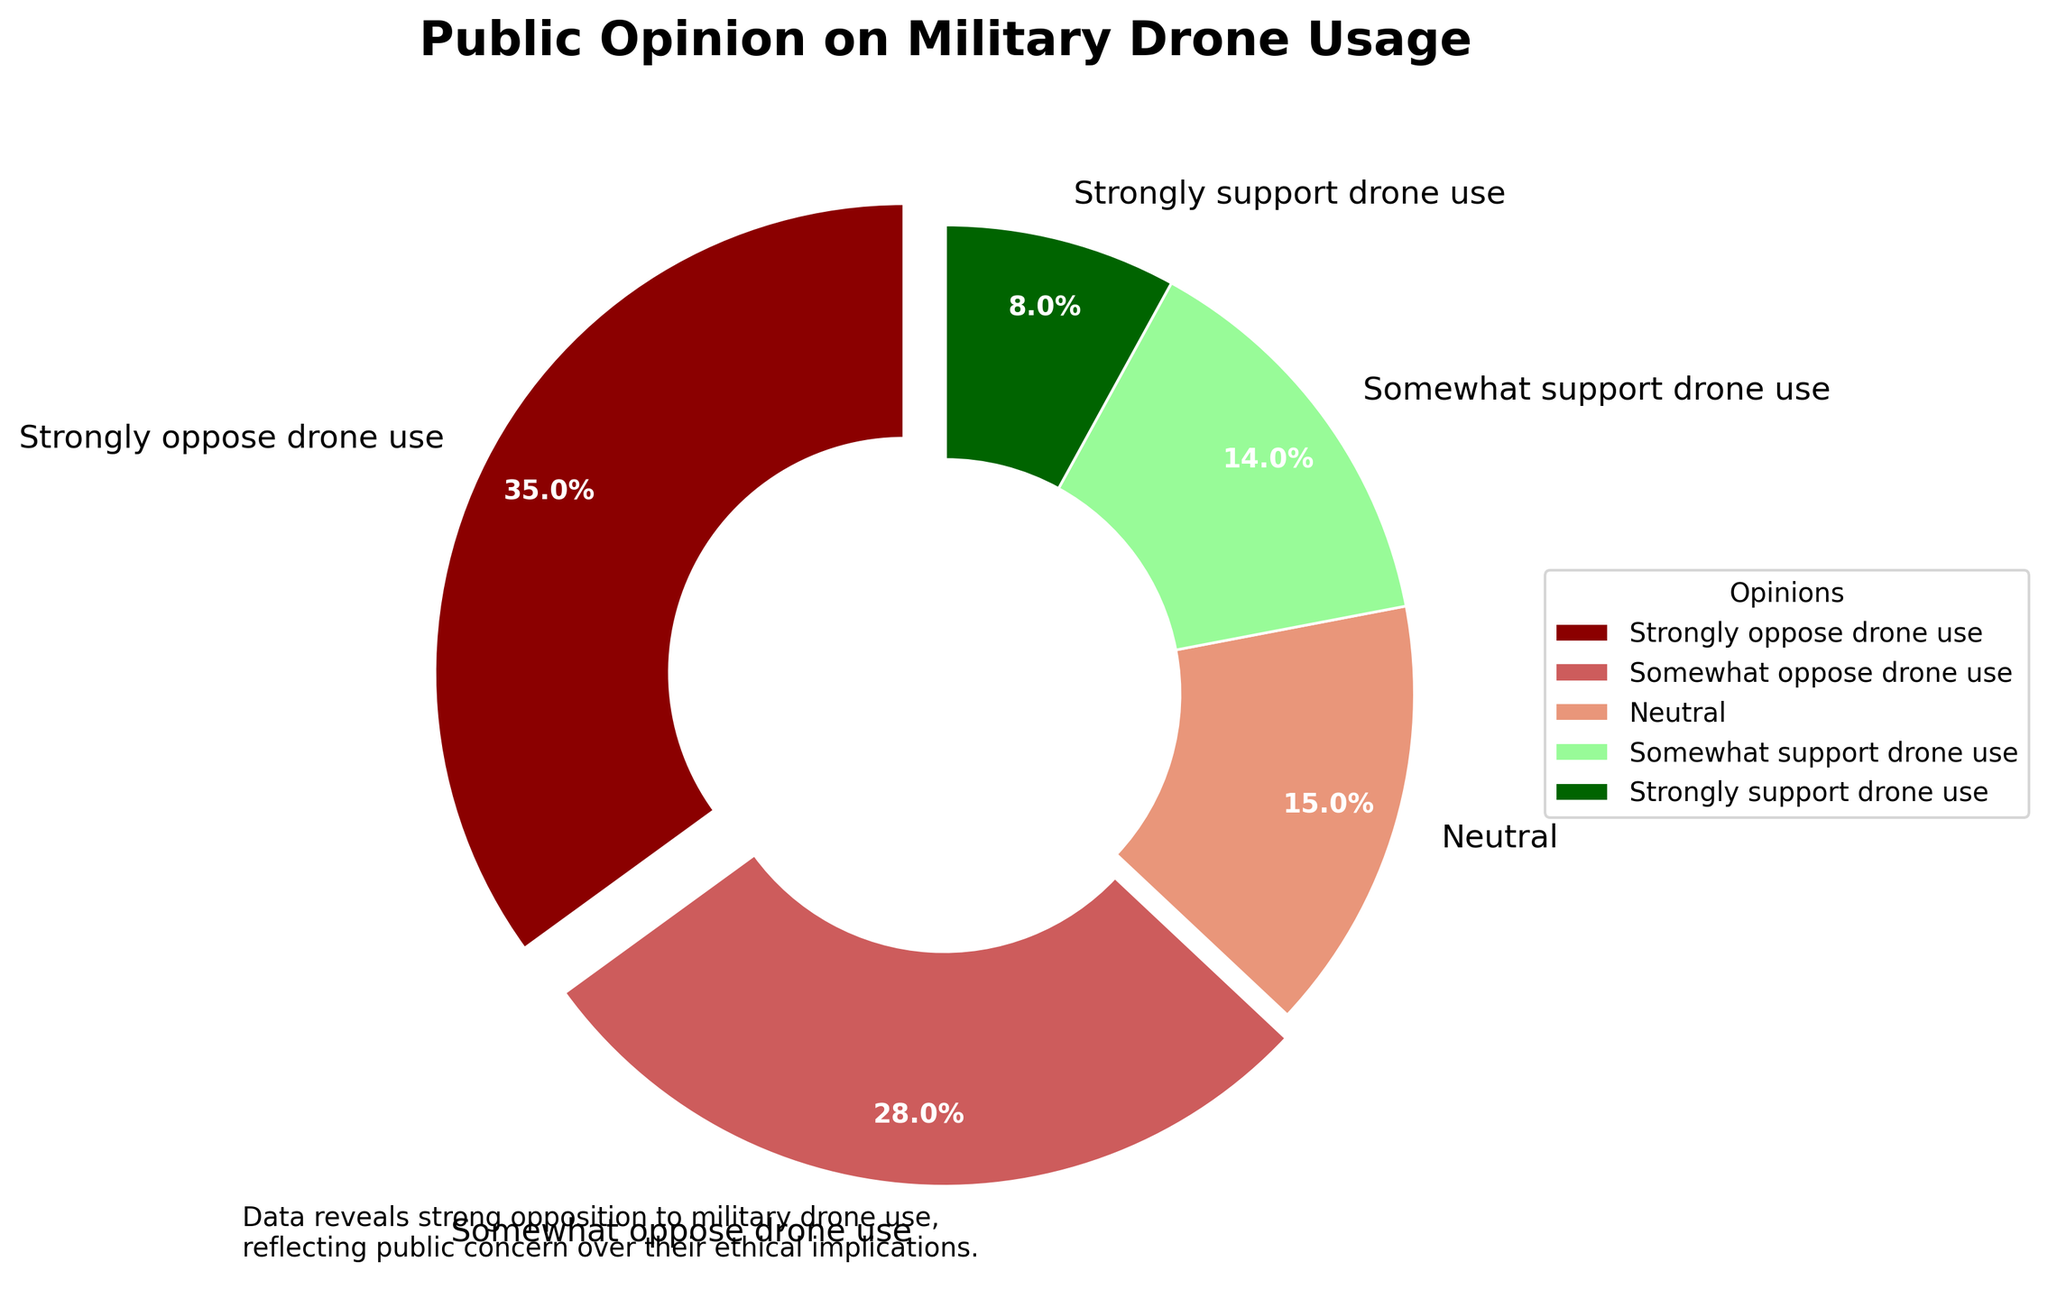what percentage of people strongly oppose or somewhat oppose military drone use? Add the percentage of people who strongly oppose (35%) and somewhat oppose (28%). 35 + 28 = 63.
Answer: 63% what's the difference in percentage between those who strongly support and those who strongly oppose drone use? Subtract the percentage of those who strongly support (8%) from those who strongly oppose (35%). 35 - 8 = 27.
Answer: 27% which opinion has the smallest percentage? The smallest percentage is 8%, which corresponds to the "Strongly support drone use" category.
Answer: Strongly support drone use are there more people neutral or somewhat supporting drone use? Compare the percentages of people who are neutral (15%) to those who somewhat support (14%). 15 > 14.
Answer: Neutral how much larger is the percentage of people who strongly oppose drone use compared to those who are neutral? Subtract the percentage of those neutral (15%) from those who strongly oppose (35%). 35 - 15 = 20.
Answer: 20% which two opinions combined make up almost half of the total percentage? Add the percentages of "Strongly oppose drone use" (35%) and "Somewhat oppose drone use" (28%). 35 + 28 = 63, which is more than half. The second closest is "Strongly oppose" (35%) and "Neutral" (15%) which sums to 50.
Answer: Strongly oppose and Somewhat oppose what color wedge represents the opinion with the highest percentage? The opinion with the highest percentage is "Strongly oppose drone use" at 35%, represented by red.
Answer: Red which segment takes up less space on the pie chart: Somewhat oppose or Somewhat support drone use? Compare the percentages of Somewhat oppose (28%) and Somewhat support (14%). 28 > 14.
Answer: Somewhat support drone use what is the difference between the sum of the two largest percentages and the sum of the two smallest percentages? The two largest percentages are "Strongly oppose drone use" (35%) and "Somewhat oppose drone use" (28%). Their sum is 35 + 28 = 63. The two smallest percentages are "Strongly support drone use" (8%) and "Somewhat support drone use" (14%). Their sum is 8 + 14 = 22. Difference is 63 - 22 = 41.
Answer: 41 